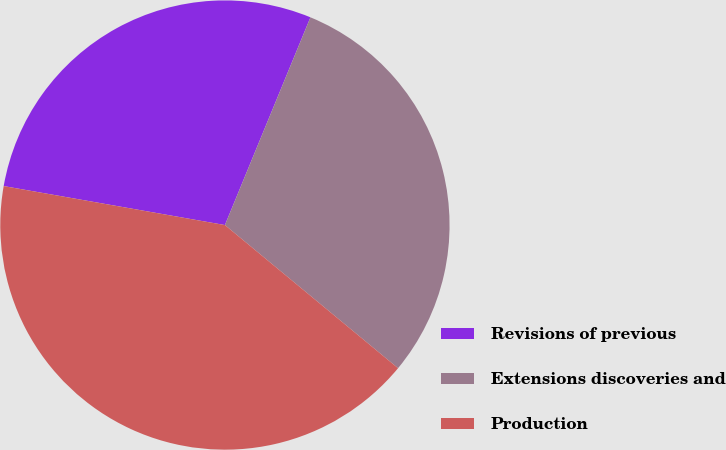<chart> <loc_0><loc_0><loc_500><loc_500><pie_chart><fcel>Revisions of previous<fcel>Extensions discoveries and<fcel>Production<nl><fcel>28.44%<fcel>29.78%<fcel>41.78%<nl></chart> 